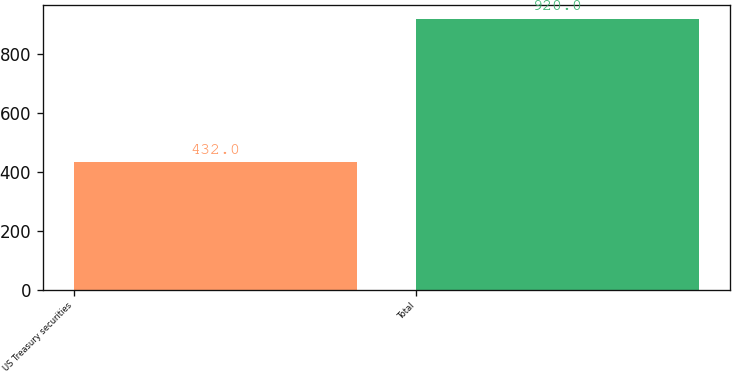Convert chart. <chart><loc_0><loc_0><loc_500><loc_500><bar_chart><fcel>US Treasury securities<fcel>Total<nl><fcel>432<fcel>920<nl></chart> 